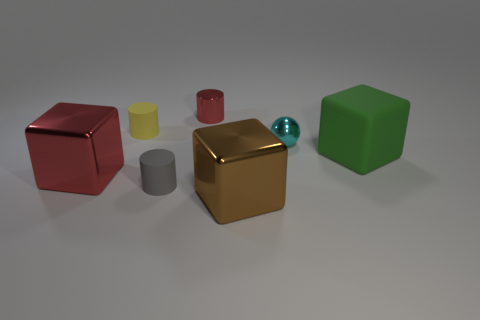There is a big thing that is the same color as the tiny metallic cylinder; what is its material?
Provide a short and direct response. Metal. How many things are both behind the green object and on the right side of the yellow thing?
Ensure brevity in your answer.  2. Is the brown block made of the same material as the green cube?
Ensure brevity in your answer.  No. What is the shape of the brown shiny thing that is the same size as the red block?
Make the answer very short. Cube. Is the number of small metallic balls greater than the number of tiny rubber things?
Give a very brief answer. No. There is a thing that is both left of the tiny gray matte thing and behind the tiny ball; what is it made of?
Your response must be concise. Rubber. How many other things are the same material as the big green object?
Offer a terse response. 2. How many large metallic objects are the same color as the shiny cylinder?
Your answer should be very brief. 1. There is a rubber cylinder behind the big object that is right of the big metal thing that is in front of the gray thing; what is its size?
Your response must be concise. Small. What number of shiny things are gray cubes or tiny gray cylinders?
Offer a terse response. 0. 